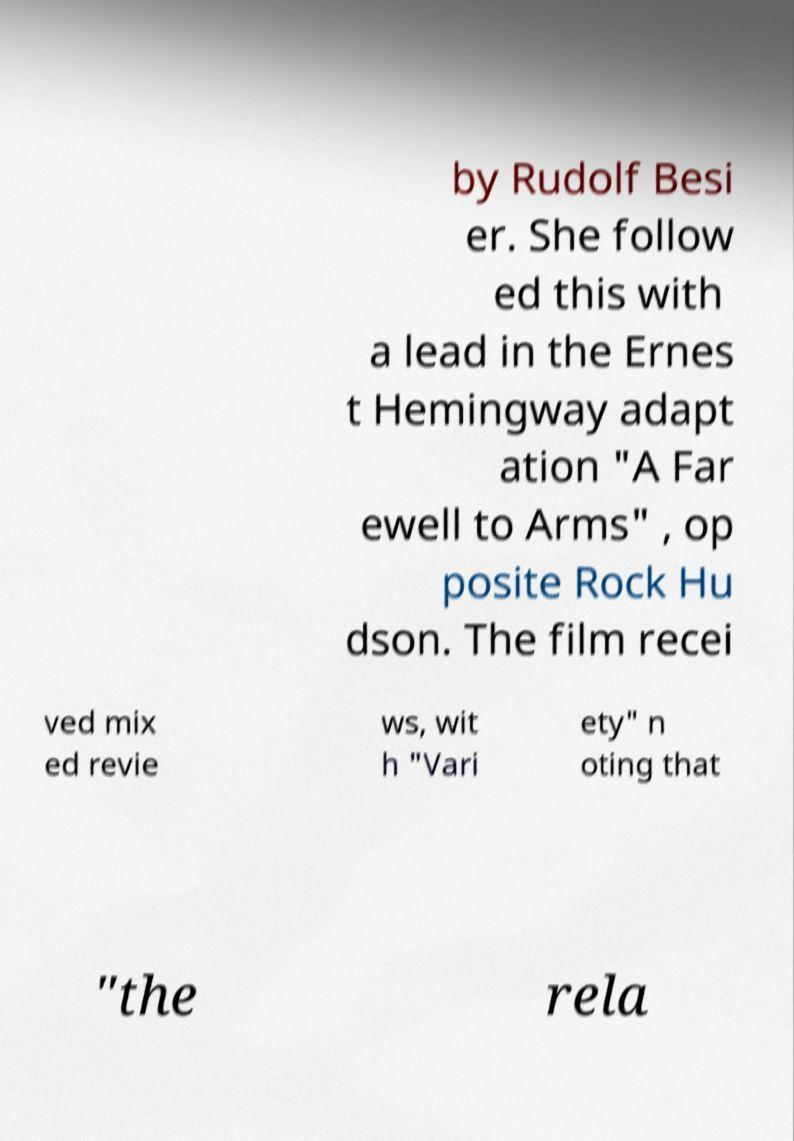Could you assist in decoding the text presented in this image and type it out clearly? by Rudolf Besi er. She follow ed this with a lead in the Ernes t Hemingway adapt ation "A Far ewell to Arms" , op posite Rock Hu dson. The film recei ved mix ed revie ws, wit h "Vari ety" n oting that "the rela 